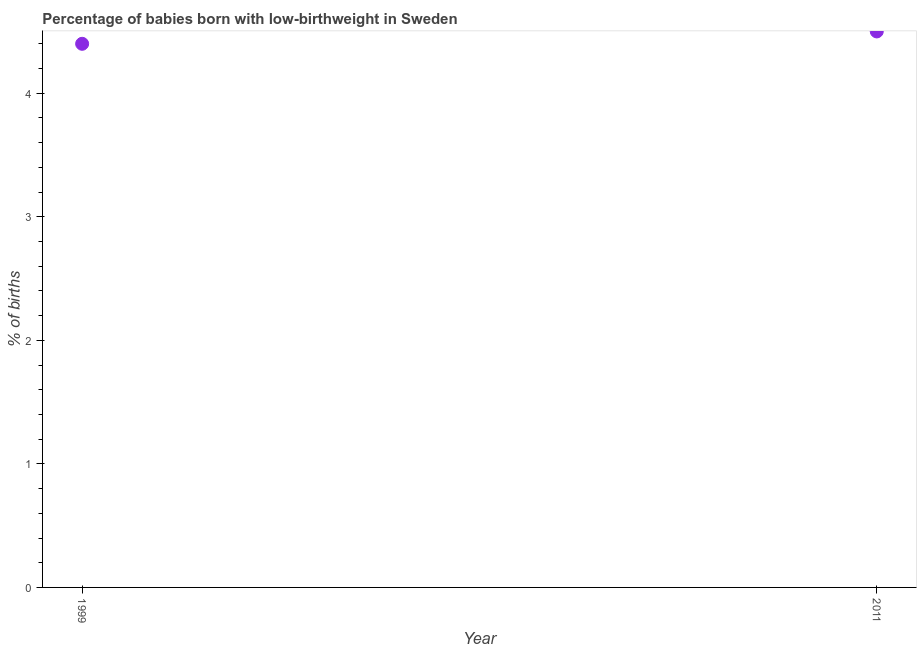Across all years, what is the maximum percentage of babies who were born with low-birthweight?
Give a very brief answer. 4.5. Across all years, what is the minimum percentage of babies who were born with low-birthweight?
Keep it short and to the point. 4.4. In which year was the percentage of babies who were born with low-birthweight minimum?
Keep it short and to the point. 1999. What is the sum of the percentage of babies who were born with low-birthweight?
Provide a short and direct response. 8.9. What is the difference between the percentage of babies who were born with low-birthweight in 1999 and 2011?
Give a very brief answer. -0.1. What is the average percentage of babies who were born with low-birthweight per year?
Keep it short and to the point. 4.45. What is the median percentage of babies who were born with low-birthweight?
Ensure brevity in your answer.  4.45. In how many years, is the percentage of babies who were born with low-birthweight greater than 1.2 %?
Ensure brevity in your answer.  2. Do a majority of the years between 1999 and 2011 (inclusive) have percentage of babies who were born with low-birthweight greater than 0.6000000000000001 %?
Keep it short and to the point. Yes. What is the ratio of the percentage of babies who were born with low-birthweight in 1999 to that in 2011?
Your answer should be compact. 0.98. Does the graph contain grids?
Offer a terse response. No. What is the title of the graph?
Provide a succinct answer. Percentage of babies born with low-birthweight in Sweden. What is the label or title of the X-axis?
Your answer should be very brief. Year. What is the label or title of the Y-axis?
Keep it short and to the point. % of births. What is the % of births in 1999?
Ensure brevity in your answer.  4.4. What is the % of births in 2011?
Your answer should be very brief. 4.5. 